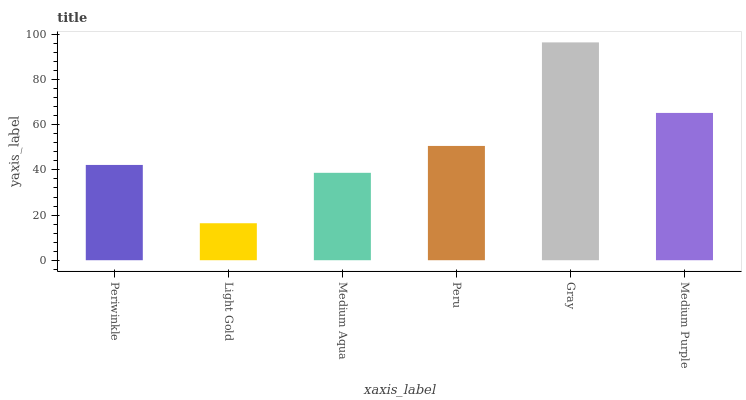Is Light Gold the minimum?
Answer yes or no. Yes. Is Gray the maximum?
Answer yes or no. Yes. Is Medium Aqua the minimum?
Answer yes or no. No. Is Medium Aqua the maximum?
Answer yes or no. No. Is Medium Aqua greater than Light Gold?
Answer yes or no. Yes. Is Light Gold less than Medium Aqua?
Answer yes or no. Yes. Is Light Gold greater than Medium Aqua?
Answer yes or no. No. Is Medium Aqua less than Light Gold?
Answer yes or no. No. Is Peru the high median?
Answer yes or no. Yes. Is Periwinkle the low median?
Answer yes or no. Yes. Is Gray the high median?
Answer yes or no. No. Is Medium Aqua the low median?
Answer yes or no. No. 